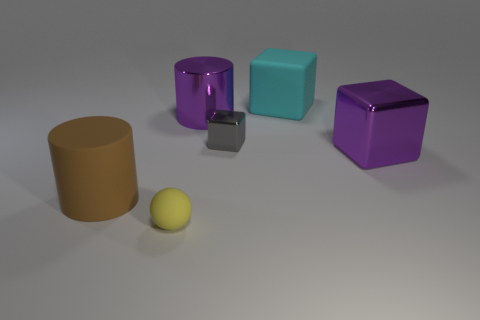Subtract all cyan blocks. How many blocks are left? 2 Subtract 1 cubes. How many cubes are left? 2 Add 4 big red metallic things. How many objects exist? 10 Subtract all balls. How many objects are left? 5 Add 2 large brown rubber cylinders. How many large brown rubber cylinders are left? 3 Add 2 large matte cylinders. How many large matte cylinders exist? 3 Subtract 0 red cylinders. How many objects are left? 6 Subtract all yellow spheres. Subtract all spheres. How many objects are left? 4 